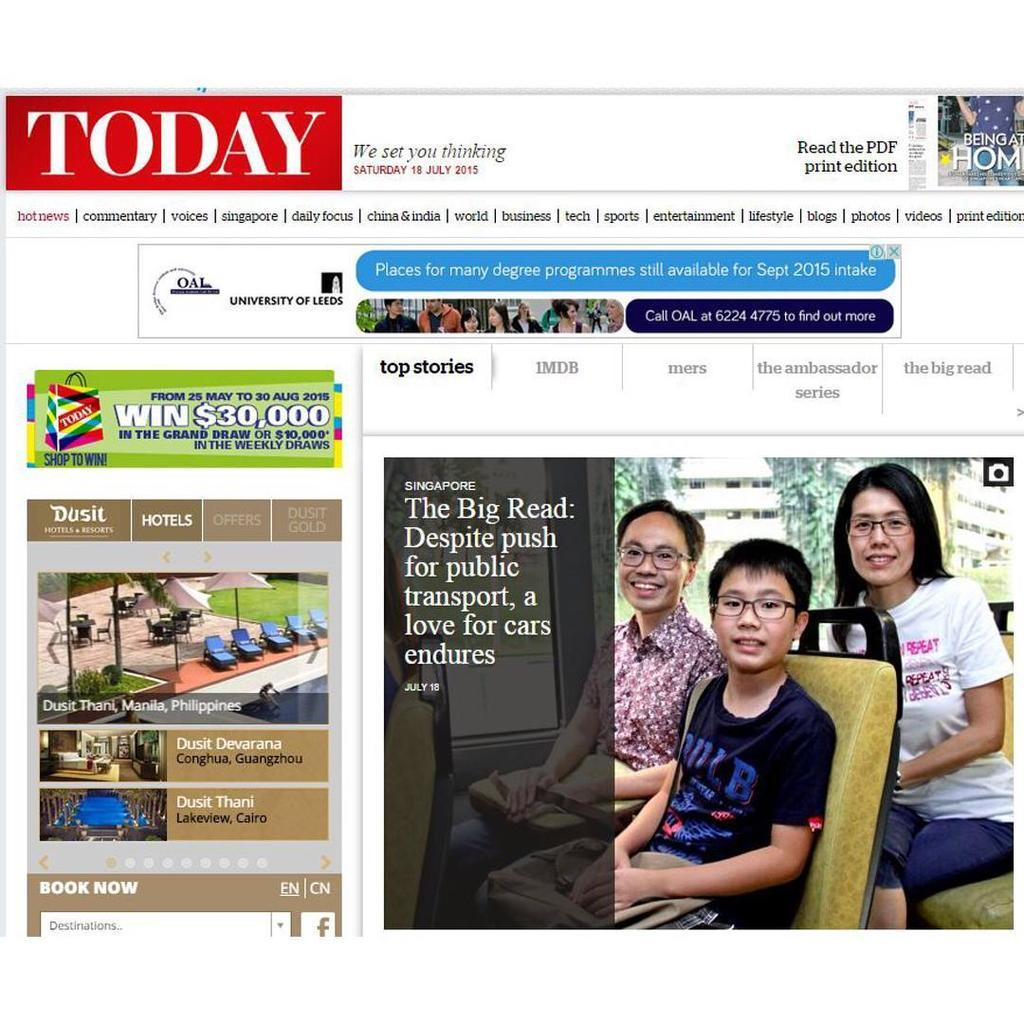Provide a one-sentence caption for the provided image. Today's website, which is dated Saturday July 18, 2015. 